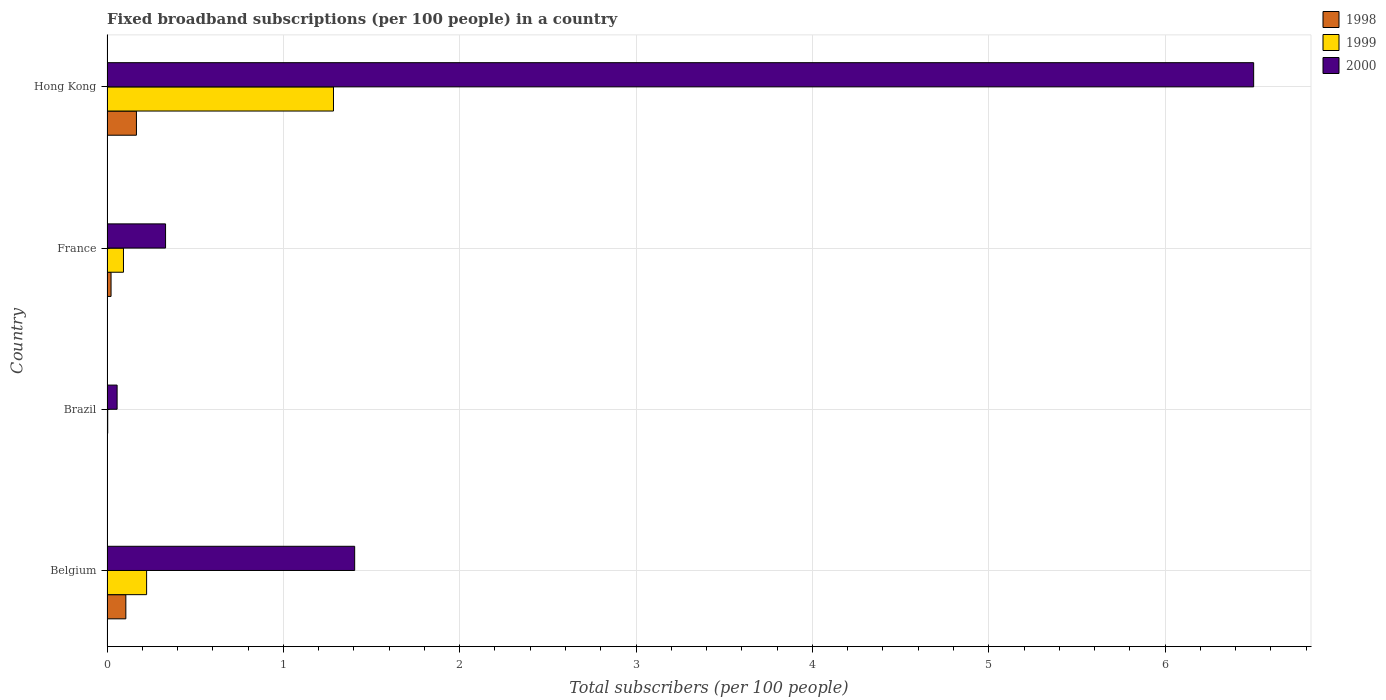Are the number of bars per tick equal to the number of legend labels?
Give a very brief answer. Yes. How many bars are there on the 3rd tick from the top?
Keep it short and to the point. 3. How many bars are there on the 1st tick from the bottom?
Provide a short and direct response. 3. What is the label of the 4th group of bars from the top?
Make the answer very short. Belgium. In how many cases, is the number of bars for a given country not equal to the number of legend labels?
Give a very brief answer. 0. What is the number of broadband subscriptions in 1998 in Belgium?
Provide a succinct answer. 0.11. Across all countries, what is the maximum number of broadband subscriptions in 2000?
Give a very brief answer. 6.5. Across all countries, what is the minimum number of broadband subscriptions in 1998?
Give a very brief answer. 0. In which country was the number of broadband subscriptions in 1999 maximum?
Offer a terse response. Hong Kong. In which country was the number of broadband subscriptions in 1998 minimum?
Your answer should be very brief. Brazil. What is the total number of broadband subscriptions in 1999 in the graph?
Offer a terse response. 1.61. What is the difference between the number of broadband subscriptions in 1999 in Brazil and that in Hong Kong?
Your answer should be very brief. -1.28. What is the difference between the number of broadband subscriptions in 1999 in Brazil and the number of broadband subscriptions in 2000 in France?
Your answer should be compact. -0.33. What is the average number of broadband subscriptions in 1998 per country?
Your answer should be compact. 0.07. What is the difference between the number of broadband subscriptions in 1999 and number of broadband subscriptions in 1998 in France?
Provide a short and direct response. 0.07. What is the ratio of the number of broadband subscriptions in 1999 in Brazil to that in France?
Provide a succinct answer. 0.04. Is the difference between the number of broadband subscriptions in 1999 in Brazil and Hong Kong greater than the difference between the number of broadband subscriptions in 1998 in Brazil and Hong Kong?
Keep it short and to the point. No. What is the difference between the highest and the second highest number of broadband subscriptions in 2000?
Give a very brief answer. 5.1. What is the difference between the highest and the lowest number of broadband subscriptions in 1998?
Keep it short and to the point. 0.17. What is the difference between two consecutive major ticks on the X-axis?
Your response must be concise. 1. Are the values on the major ticks of X-axis written in scientific E-notation?
Your answer should be compact. No. How are the legend labels stacked?
Keep it short and to the point. Vertical. What is the title of the graph?
Provide a succinct answer. Fixed broadband subscriptions (per 100 people) in a country. What is the label or title of the X-axis?
Your response must be concise. Total subscribers (per 100 people). What is the Total subscribers (per 100 people) in 1998 in Belgium?
Your answer should be compact. 0.11. What is the Total subscribers (per 100 people) of 1999 in Belgium?
Provide a short and direct response. 0.22. What is the Total subscribers (per 100 people) in 2000 in Belgium?
Your answer should be compact. 1.4. What is the Total subscribers (per 100 people) in 1998 in Brazil?
Keep it short and to the point. 0. What is the Total subscribers (per 100 people) of 1999 in Brazil?
Your answer should be compact. 0. What is the Total subscribers (per 100 people) of 2000 in Brazil?
Ensure brevity in your answer.  0.06. What is the Total subscribers (per 100 people) of 1998 in France?
Make the answer very short. 0.02. What is the Total subscribers (per 100 people) of 1999 in France?
Your answer should be very brief. 0.09. What is the Total subscribers (per 100 people) of 2000 in France?
Provide a short and direct response. 0.33. What is the Total subscribers (per 100 people) in 1998 in Hong Kong?
Make the answer very short. 0.17. What is the Total subscribers (per 100 people) in 1999 in Hong Kong?
Provide a short and direct response. 1.28. What is the Total subscribers (per 100 people) in 2000 in Hong Kong?
Offer a terse response. 6.5. Across all countries, what is the maximum Total subscribers (per 100 people) in 1998?
Your response must be concise. 0.17. Across all countries, what is the maximum Total subscribers (per 100 people) in 1999?
Your answer should be compact. 1.28. Across all countries, what is the maximum Total subscribers (per 100 people) in 2000?
Your answer should be compact. 6.5. Across all countries, what is the minimum Total subscribers (per 100 people) in 1998?
Give a very brief answer. 0. Across all countries, what is the minimum Total subscribers (per 100 people) of 1999?
Offer a very short reply. 0. Across all countries, what is the minimum Total subscribers (per 100 people) of 2000?
Provide a succinct answer. 0.06. What is the total Total subscribers (per 100 people) of 1998 in the graph?
Provide a short and direct response. 0.3. What is the total Total subscribers (per 100 people) of 1999 in the graph?
Your answer should be compact. 1.61. What is the total Total subscribers (per 100 people) in 2000 in the graph?
Give a very brief answer. 8.3. What is the difference between the Total subscribers (per 100 people) of 1998 in Belgium and that in Brazil?
Make the answer very short. 0.11. What is the difference between the Total subscribers (per 100 people) in 1999 in Belgium and that in Brazil?
Ensure brevity in your answer.  0.22. What is the difference between the Total subscribers (per 100 people) of 2000 in Belgium and that in Brazil?
Offer a very short reply. 1.35. What is the difference between the Total subscribers (per 100 people) in 1998 in Belgium and that in France?
Provide a succinct answer. 0.08. What is the difference between the Total subscribers (per 100 people) of 1999 in Belgium and that in France?
Provide a short and direct response. 0.13. What is the difference between the Total subscribers (per 100 people) in 2000 in Belgium and that in France?
Provide a short and direct response. 1.07. What is the difference between the Total subscribers (per 100 people) of 1998 in Belgium and that in Hong Kong?
Your answer should be compact. -0.06. What is the difference between the Total subscribers (per 100 people) in 1999 in Belgium and that in Hong Kong?
Give a very brief answer. -1.06. What is the difference between the Total subscribers (per 100 people) in 2000 in Belgium and that in Hong Kong?
Your answer should be compact. -5.1. What is the difference between the Total subscribers (per 100 people) of 1998 in Brazil and that in France?
Offer a very short reply. -0.02. What is the difference between the Total subscribers (per 100 people) in 1999 in Brazil and that in France?
Provide a succinct answer. -0.09. What is the difference between the Total subscribers (per 100 people) of 2000 in Brazil and that in France?
Your response must be concise. -0.27. What is the difference between the Total subscribers (per 100 people) of 1998 in Brazil and that in Hong Kong?
Your response must be concise. -0.17. What is the difference between the Total subscribers (per 100 people) of 1999 in Brazil and that in Hong Kong?
Give a very brief answer. -1.28. What is the difference between the Total subscribers (per 100 people) in 2000 in Brazil and that in Hong Kong?
Give a very brief answer. -6.45. What is the difference between the Total subscribers (per 100 people) in 1998 in France and that in Hong Kong?
Provide a succinct answer. -0.14. What is the difference between the Total subscribers (per 100 people) in 1999 in France and that in Hong Kong?
Keep it short and to the point. -1.19. What is the difference between the Total subscribers (per 100 people) of 2000 in France and that in Hong Kong?
Give a very brief answer. -6.17. What is the difference between the Total subscribers (per 100 people) of 1998 in Belgium and the Total subscribers (per 100 people) of 1999 in Brazil?
Ensure brevity in your answer.  0.1. What is the difference between the Total subscribers (per 100 people) in 1998 in Belgium and the Total subscribers (per 100 people) in 2000 in Brazil?
Offer a very short reply. 0.05. What is the difference between the Total subscribers (per 100 people) in 1999 in Belgium and the Total subscribers (per 100 people) in 2000 in Brazil?
Your answer should be compact. 0.17. What is the difference between the Total subscribers (per 100 people) of 1998 in Belgium and the Total subscribers (per 100 people) of 1999 in France?
Your answer should be compact. 0.01. What is the difference between the Total subscribers (per 100 people) in 1998 in Belgium and the Total subscribers (per 100 people) in 2000 in France?
Make the answer very short. -0.23. What is the difference between the Total subscribers (per 100 people) of 1999 in Belgium and the Total subscribers (per 100 people) of 2000 in France?
Offer a terse response. -0.11. What is the difference between the Total subscribers (per 100 people) in 1998 in Belgium and the Total subscribers (per 100 people) in 1999 in Hong Kong?
Your answer should be compact. -1.18. What is the difference between the Total subscribers (per 100 people) in 1998 in Belgium and the Total subscribers (per 100 people) in 2000 in Hong Kong?
Provide a short and direct response. -6.4. What is the difference between the Total subscribers (per 100 people) in 1999 in Belgium and the Total subscribers (per 100 people) in 2000 in Hong Kong?
Your response must be concise. -6.28. What is the difference between the Total subscribers (per 100 people) in 1998 in Brazil and the Total subscribers (per 100 people) in 1999 in France?
Make the answer very short. -0.09. What is the difference between the Total subscribers (per 100 people) of 1998 in Brazil and the Total subscribers (per 100 people) of 2000 in France?
Keep it short and to the point. -0.33. What is the difference between the Total subscribers (per 100 people) in 1999 in Brazil and the Total subscribers (per 100 people) in 2000 in France?
Offer a terse response. -0.33. What is the difference between the Total subscribers (per 100 people) in 1998 in Brazil and the Total subscribers (per 100 people) in 1999 in Hong Kong?
Your answer should be compact. -1.28. What is the difference between the Total subscribers (per 100 people) of 1998 in Brazil and the Total subscribers (per 100 people) of 2000 in Hong Kong?
Ensure brevity in your answer.  -6.5. What is the difference between the Total subscribers (per 100 people) of 1999 in Brazil and the Total subscribers (per 100 people) of 2000 in Hong Kong?
Make the answer very short. -6.5. What is the difference between the Total subscribers (per 100 people) of 1998 in France and the Total subscribers (per 100 people) of 1999 in Hong Kong?
Offer a terse response. -1.26. What is the difference between the Total subscribers (per 100 people) of 1998 in France and the Total subscribers (per 100 people) of 2000 in Hong Kong?
Keep it short and to the point. -6.48. What is the difference between the Total subscribers (per 100 people) in 1999 in France and the Total subscribers (per 100 people) in 2000 in Hong Kong?
Make the answer very short. -6.41. What is the average Total subscribers (per 100 people) in 1998 per country?
Provide a short and direct response. 0.07. What is the average Total subscribers (per 100 people) in 1999 per country?
Give a very brief answer. 0.4. What is the average Total subscribers (per 100 people) of 2000 per country?
Your answer should be very brief. 2.07. What is the difference between the Total subscribers (per 100 people) in 1998 and Total subscribers (per 100 people) in 1999 in Belgium?
Ensure brevity in your answer.  -0.12. What is the difference between the Total subscribers (per 100 people) in 1998 and Total subscribers (per 100 people) in 2000 in Belgium?
Your answer should be compact. -1.3. What is the difference between the Total subscribers (per 100 people) in 1999 and Total subscribers (per 100 people) in 2000 in Belgium?
Provide a succinct answer. -1.18. What is the difference between the Total subscribers (per 100 people) in 1998 and Total subscribers (per 100 people) in 1999 in Brazil?
Offer a terse response. -0. What is the difference between the Total subscribers (per 100 people) of 1998 and Total subscribers (per 100 people) of 2000 in Brazil?
Make the answer very short. -0.06. What is the difference between the Total subscribers (per 100 people) of 1999 and Total subscribers (per 100 people) of 2000 in Brazil?
Give a very brief answer. -0.05. What is the difference between the Total subscribers (per 100 people) of 1998 and Total subscribers (per 100 people) of 1999 in France?
Make the answer very short. -0.07. What is the difference between the Total subscribers (per 100 people) of 1998 and Total subscribers (per 100 people) of 2000 in France?
Keep it short and to the point. -0.31. What is the difference between the Total subscribers (per 100 people) of 1999 and Total subscribers (per 100 people) of 2000 in France?
Keep it short and to the point. -0.24. What is the difference between the Total subscribers (per 100 people) of 1998 and Total subscribers (per 100 people) of 1999 in Hong Kong?
Your answer should be compact. -1.12. What is the difference between the Total subscribers (per 100 people) in 1998 and Total subscribers (per 100 people) in 2000 in Hong Kong?
Offer a very short reply. -6.34. What is the difference between the Total subscribers (per 100 people) of 1999 and Total subscribers (per 100 people) of 2000 in Hong Kong?
Give a very brief answer. -5.22. What is the ratio of the Total subscribers (per 100 people) of 1998 in Belgium to that in Brazil?
Provide a succinct answer. 181.1. What is the ratio of the Total subscribers (per 100 people) of 1999 in Belgium to that in Brazil?
Make the answer very short. 55.18. What is the ratio of the Total subscribers (per 100 people) of 2000 in Belgium to that in Brazil?
Your answer should be very brief. 24.51. What is the ratio of the Total subscribers (per 100 people) in 1998 in Belgium to that in France?
Offer a terse response. 4.65. What is the ratio of the Total subscribers (per 100 people) of 1999 in Belgium to that in France?
Keep it short and to the point. 2.4. What is the ratio of the Total subscribers (per 100 people) of 2000 in Belgium to that in France?
Offer a terse response. 4.23. What is the ratio of the Total subscribers (per 100 people) of 1998 in Belgium to that in Hong Kong?
Ensure brevity in your answer.  0.64. What is the ratio of the Total subscribers (per 100 people) in 1999 in Belgium to that in Hong Kong?
Give a very brief answer. 0.17. What is the ratio of the Total subscribers (per 100 people) of 2000 in Belgium to that in Hong Kong?
Your response must be concise. 0.22. What is the ratio of the Total subscribers (per 100 people) in 1998 in Brazil to that in France?
Your answer should be compact. 0.03. What is the ratio of the Total subscribers (per 100 people) in 1999 in Brazil to that in France?
Provide a short and direct response. 0.04. What is the ratio of the Total subscribers (per 100 people) of 2000 in Brazil to that in France?
Ensure brevity in your answer.  0.17. What is the ratio of the Total subscribers (per 100 people) in 1998 in Brazil to that in Hong Kong?
Ensure brevity in your answer.  0. What is the ratio of the Total subscribers (per 100 people) in 1999 in Brazil to that in Hong Kong?
Provide a short and direct response. 0. What is the ratio of the Total subscribers (per 100 people) of 2000 in Brazil to that in Hong Kong?
Your response must be concise. 0.01. What is the ratio of the Total subscribers (per 100 people) in 1998 in France to that in Hong Kong?
Your answer should be compact. 0.14. What is the ratio of the Total subscribers (per 100 people) in 1999 in France to that in Hong Kong?
Give a very brief answer. 0.07. What is the ratio of the Total subscribers (per 100 people) of 2000 in France to that in Hong Kong?
Offer a terse response. 0.05. What is the difference between the highest and the second highest Total subscribers (per 100 people) in 1998?
Keep it short and to the point. 0.06. What is the difference between the highest and the second highest Total subscribers (per 100 people) in 1999?
Your answer should be compact. 1.06. What is the difference between the highest and the second highest Total subscribers (per 100 people) in 2000?
Make the answer very short. 5.1. What is the difference between the highest and the lowest Total subscribers (per 100 people) of 1998?
Keep it short and to the point. 0.17. What is the difference between the highest and the lowest Total subscribers (per 100 people) of 1999?
Your answer should be very brief. 1.28. What is the difference between the highest and the lowest Total subscribers (per 100 people) of 2000?
Make the answer very short. 6.45. 